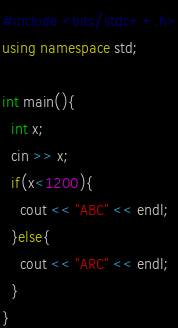<code> <loc_0><loc_0><loc_500><loc_500><_C++_>#include <bits/stdc++.h>
using namespace std;

int main(){
  int x;
  cin >> x;
  if(x<1200){
    cout << "ABC" << endl;
  }else{
    cout << "ARC" << endl;
  }
}</code> 